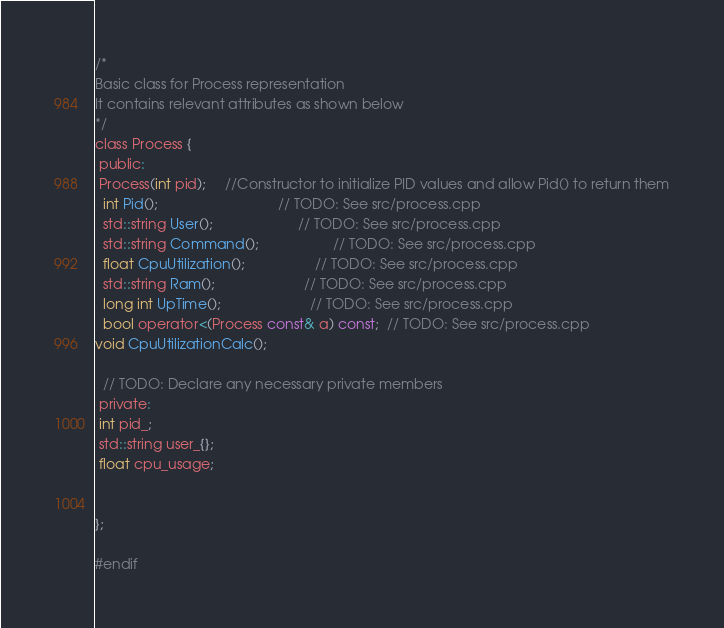<code> <loc_0><loc_0><loc_500><loc_500><_C_>
/*
Basic class for Process representation
It contains relevant attributes as shown below
*/
class Process {
 public:
 Process(int pid);     //Constructor to initialize PID values and allow Pid() to return them
  int Pid();                               // TODO: See src/process.cpp
  std::string User();                      // TODO: See src/process.cpp
  std::string Command();                   // TODO: See src/process.cpp
  float CpuUtilization();                  // TODO: See src/process.cpp
  std::string Ram();                       // TODO: See src/process.cpp
  long int UpTime();                       // TODO: See src/process.cpp
  bool operator<(Process const& a) const;  // TODO: See src/process.cpp
void CpuUtilizationCalc();

  // TODO: Declare any necessary private members
 private:
 int pid_;
 std::string user_{};
 float cpu_usage;
 
 
};

#endif</code> 